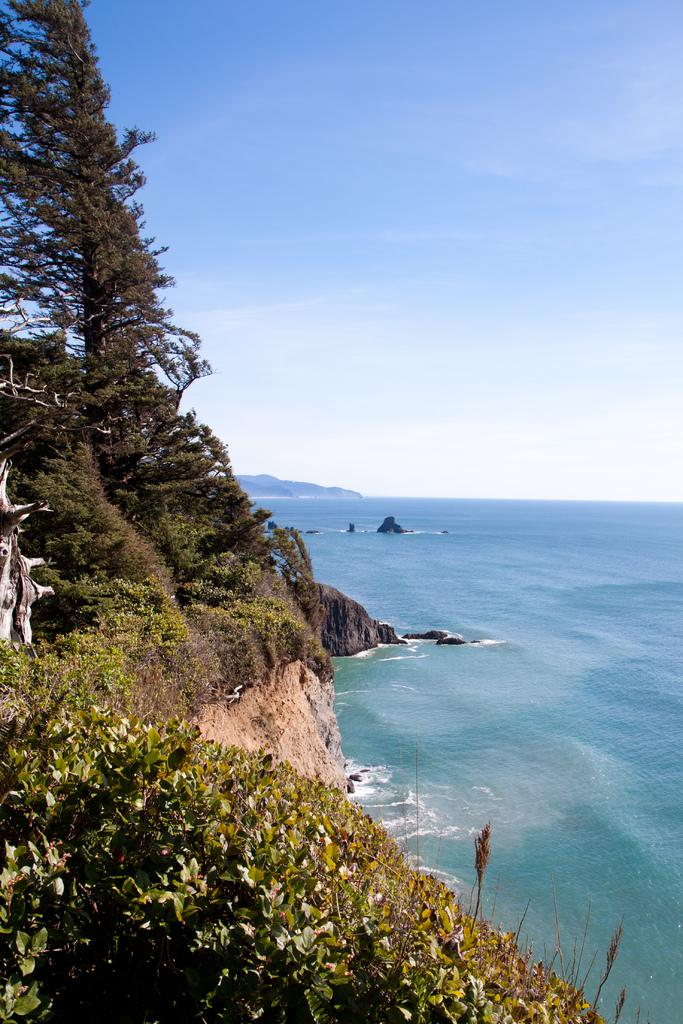What type of living organisms can be seen in the image? Plants can be seen in the image. What is located on the right side of the image? There is water on the right side of the image. What type of natural features are present in the image? There are rocks in the image. What can be seen in the background of the image? Mountains and the sky are visible in the background of the image. What type of acoustics can be heard in the image? There is no sound or acoustics present in the image, as it is a still photograph. Is there a bed visible in the image? No, there is no bed present in the image. 